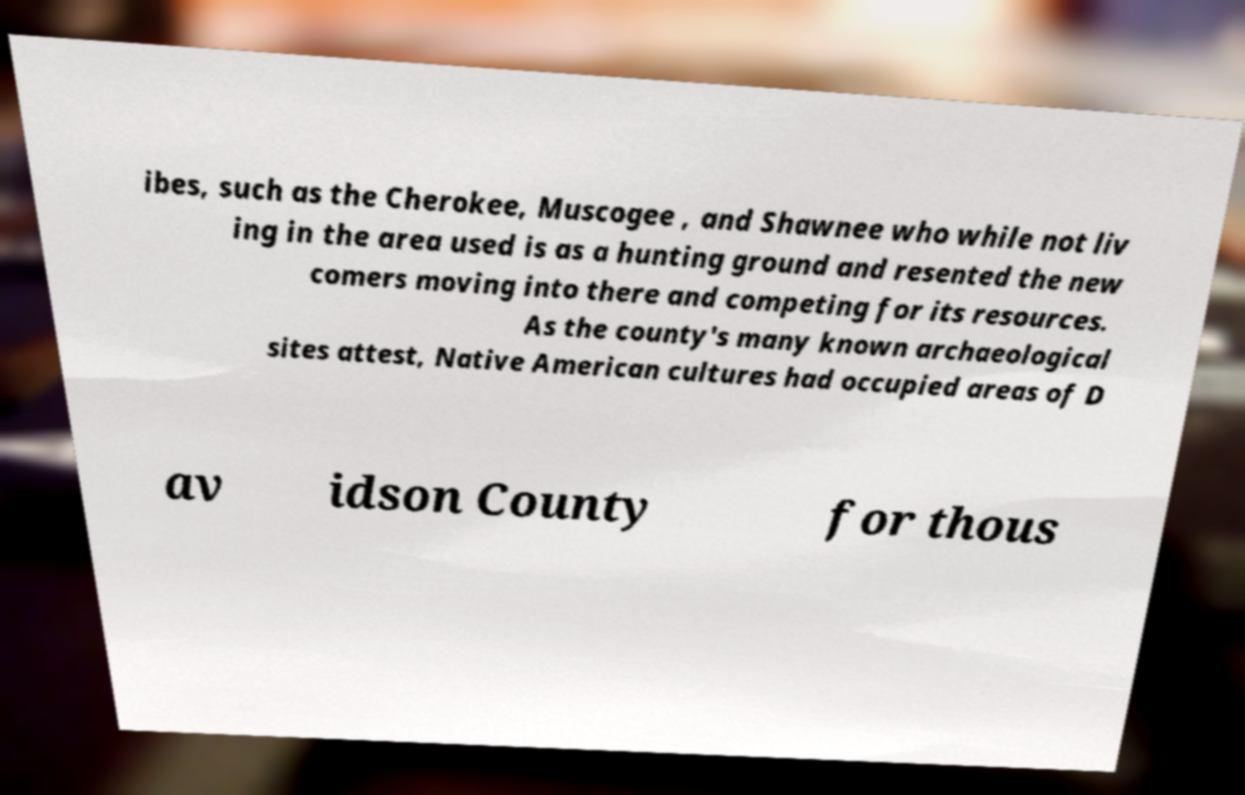What messages or text are displayed in this image? I need them in a readable, typed format. ibes, such as the Cherokee, Muscogee , and Shawnee who while not liv ing in the area used is as a hunting ground and resented the new comers moving into there and competing for its resources. As the county's many known archaeological sites attest, Native American cultures had occupied areas of D av idson County for thous 